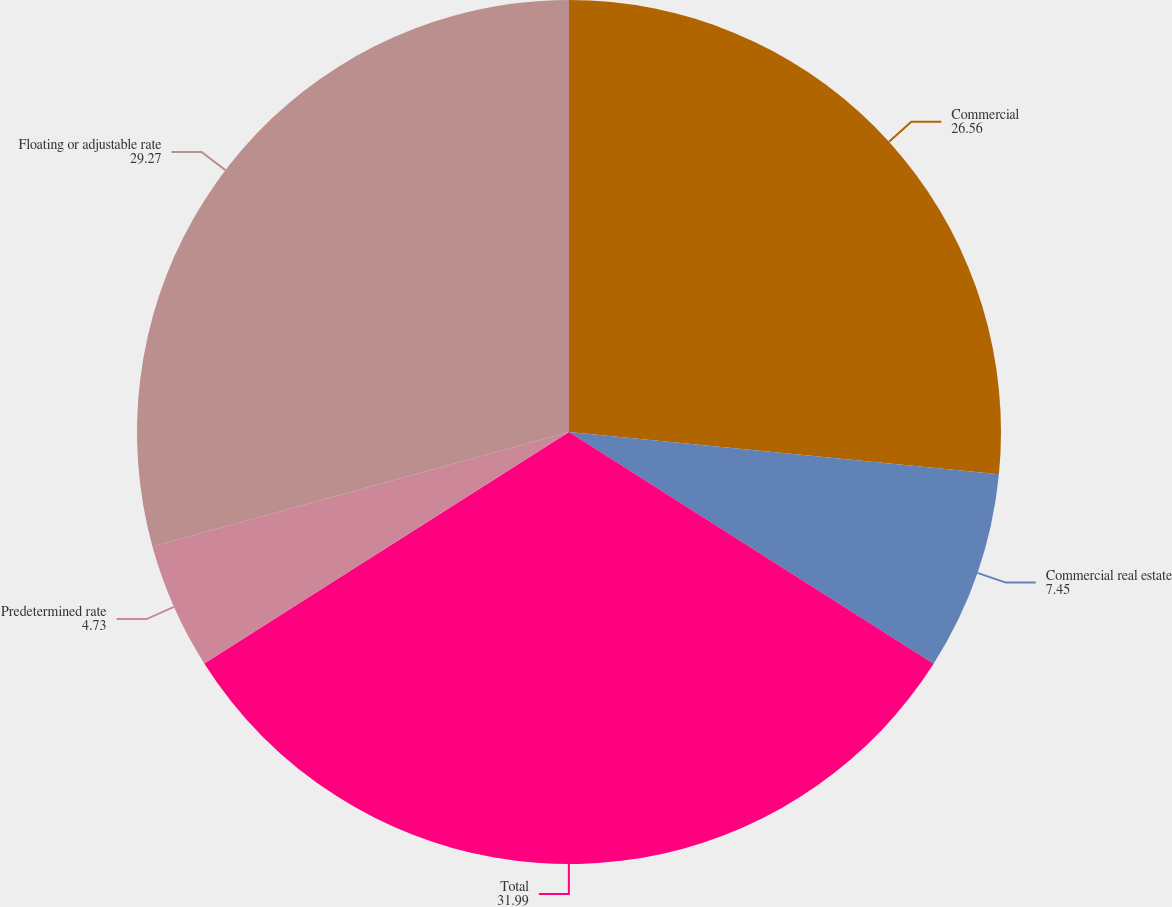Convert chart. <chart><loc_0><loc_0><loc_500><loc_500><pie_chart><fcel>Commercial<fcel>Commercial real estate<fcel>Total<fcel>Predetermined rate<fcel>Floating or adjustable rate<nl><fcel>26.56%<fcel>7.45%<fcel>31.99%<fcel>4.73%<fcel>29.27%<nl></chart> 